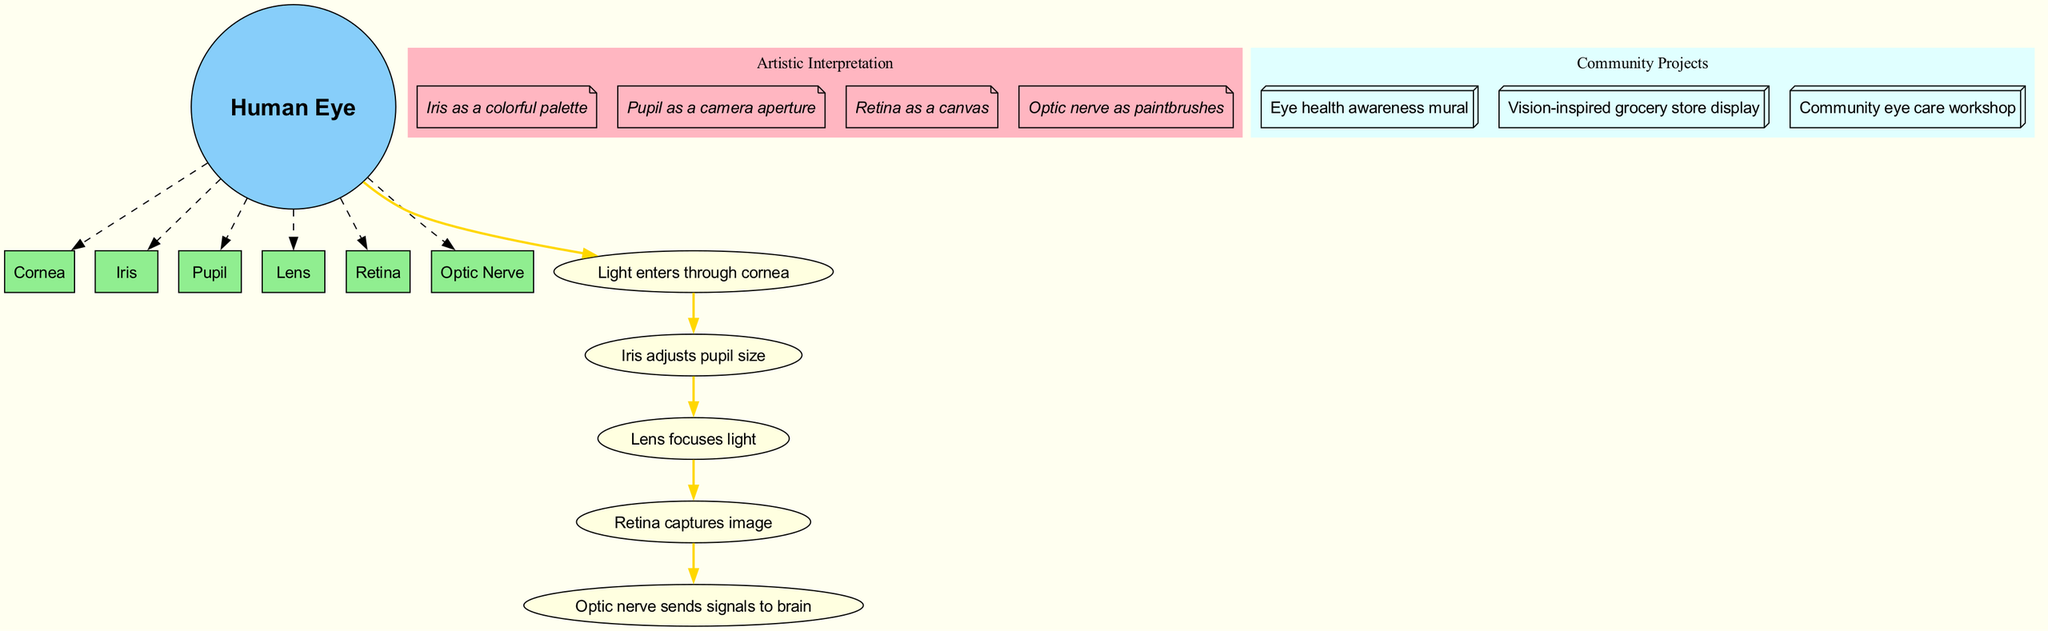What is the central node of the diagram? The central node is labeled "Human Eye," which serves as the focal point of the diagram.
Answer: Human Eye How many main structures are depicted in the diagram? The diagram lists six main structures related to the human eye, which are visually represented as boxes connected to the central node.
Answer: 6 What does the iris adjust? The diagram states that the iris adjusts the "pupil size," indicating its function in regulating light entry into the eye.
Answer: Pupil size Which structure captures the image? According to the diagram, the "Retina" is responsible for capturing the image, as indicated by the flow of information leading to this structure.
Answer: Retina What color is used for the main structures? The main structures are colored "light green," which is visually distinguishable from other components in the diagram, such as artistic elements.
Answer: Light green What is the artistic representation of the optic nerve? The optic nerve is artistically represented as "paintbrushes," indicating its role in conveying visual information, as conveyed in the artistic elements cluster.
Answer: Paintbrushes Describe the flow of light processing from the cornea to the brain. Light processing begins with light entering through the cornea, passing through the iris that adjusts the pupil size, then focuses through the lens, captured by the retina, and finally, the optic nerve sends signals to the brain. This flow is depicted sequentially in the diagram, illustrating how light is processed.
Answer: Cornea, Iris, Lens, Retina, Optic Nerve What community project is related to eye health awareness? The diagram mentions an "Eye health awareness mural" as a community connection that raises awareness about eye health, indicating collaboration with the community on educational art projects.
Answer: Eye health awareness mural How does the lens affect light? The lens functions to "focus light," which is a crucial step in the light processing sequence depicted in the diagram as it specifically helps in image clarity.
Answer: Focuses light 